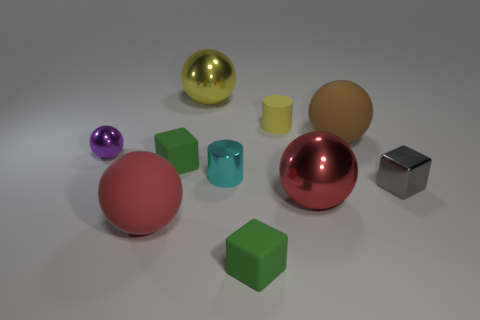How many small cylinders are the same color as the small ball?
Ensure brevity in your answer.  0. Is the tiny shiny sphere the same color as the metal cylinder?
Provide a succinct answer. No. What is the material of the red sphere left of the tiny cyan shiny thing?
Your response must be concise. Rubber. How many big objects are red shiny things or shiny cylinders?
Keep it short and to the point. 1. There is a ball that is the same color as the tiny rubber cylinder; what is its material?
Keep it short and to the point. Metal. Are there any tiny yellow cylinders made of the same material as the tiny cyan cylinder?
Offer a very short reply. No. There is a cylinder that is left of the matte cylinder; is its size the same as the shiny cube?
Provide a succinct answer. Yes. Is there a big red shiny object behind the metal ball that is in front of the purple object that is behind the small gray metal block?
Your response must be concise. No. How many matte things are tiny balls or large red objects?
Offer a terse response. 1. What number of other things are the same shape as the small gray thing?
Your response must be concise. 2. 